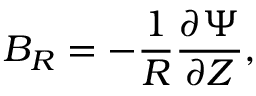Convert formula to latex. <formula><loc_0><loc_0><loc_500><loc_500>B _ { R } = - \frac { 1 } { R } \frac { \partial \Psi } { \partial Z } ,</formula> 